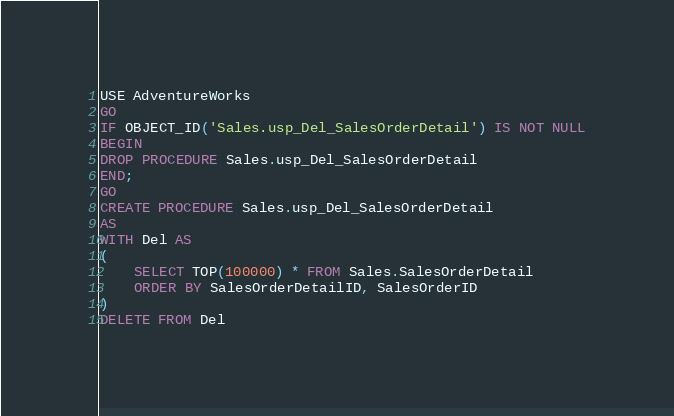<code> <loc_0><loc_0><loc_500><loc_500><_SQL_>USE AdventureWorks
GO
IF OBJECT_ID('Sales.usp_Del_SalesOrderDetail') IS NOT NULL
BEGIN
DROP PROCEDURE Sales.usp_Del_SalesOrderDetail
END;
GO
CREATE PROCEDURE Sales.usp_Del_SalesOrderDetail
AS
WITH Del AS 
(
	SELECT TOP(100000) * FROM Sales.SalesOrderDetail
	ORDER BY SalesOrderDetailID, SalesOrderID
) 
DELETE FROM Del

</code> 